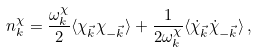<formula> <loc_0><loc_0><loc_500><loc_500>n _ { k } ^ { \chi } = \frac { \omega ^ { \chi } _ { k } } { 2 } \langle \chi _ { \vec { k } } \chi _ { - \vec { k } } \rangle + \frac { 1 } { 2 \omega _ { k } ^ { \chi } } \langle \dot { \chi } _ { \vec { k } } \dot { \chi } _ { - \vec { k } } \rangle \, ,</formula> 